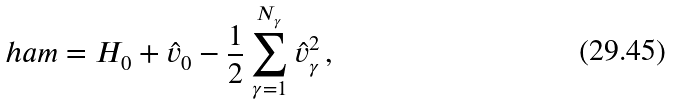<formula> <loc_0><loc_0><loc_500><loc_500>\ h a m = H _ { 0 } + \hat { v } _ { 0 } - \frac { 1 } { 2 } \sum _ { \gamma = 1 } ^ { N _ { \gamma } } \hat { v } _ { \gamma } ^ { 2 } \, , \,</formula> 